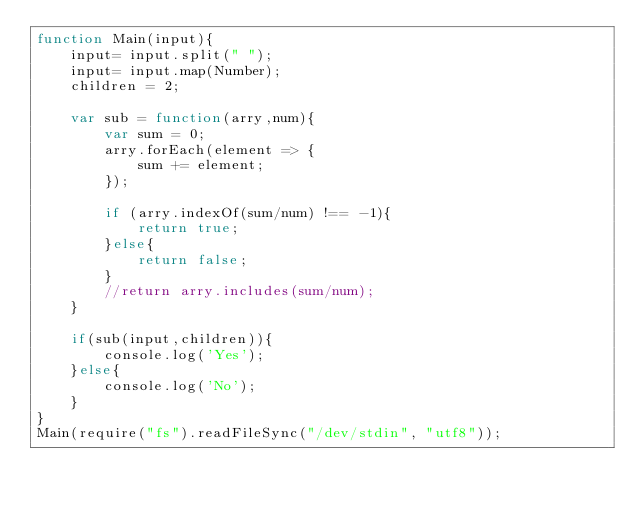<code> <loc_0><loc_0><loc_500><loc_500><_JavaScript_>function Main(input){
    input= input.split(" ");
    input= input.map(Number);
    children = 2;
    
    var sub = function(arry,num){
        var sum = 0;
        arry.forEach(element => {
            sum += element;
        });
        
        if (arry.indexOf(sum/num) !== -1){
            return true;
        }else{
            return false;
        }
        //return arry.includes(sum/num);
    }
    
    if(sub(input,children)){
        console.log('Yes');
    }else{
        console.log('No');
    }
}
Main(require("fs").readFileSync("/dev/stdin", "utf8")); </code> 